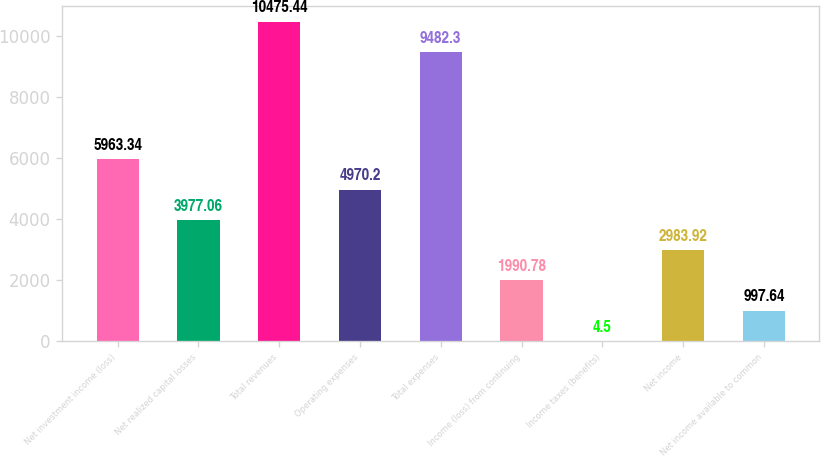Convert chart to OTSL. <chart><loc_0><loc_0><loc_500><loc_500><bar_chart><fcel>Net investment income (loss)<fcel>Net realized capital losses<fcel>Total revenues<fcel>Operating expenses<fcel>Total expenses<fcel>Income (loss) from continuing<fcel>Income taxes (benefits)<fcel>Net income<fcel>Net income available to common<nl><fcel>5963.34<fcel>3977.06<fcel>10475.4<fcel>4970.2<fcel>9482.3<fcel>1990.78<fcel>4.5<fcel>2983.92<fcel>997.64<nl></chart> 